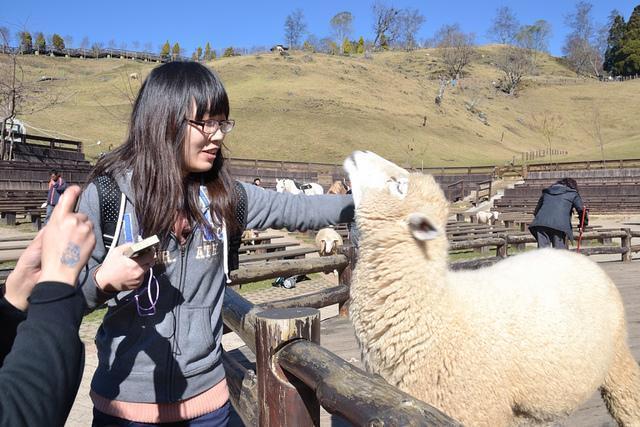How many people are in the picture?
Give a very brief answer. 3. How many airplanes are in the water?
Give a very brief answer. 0. 